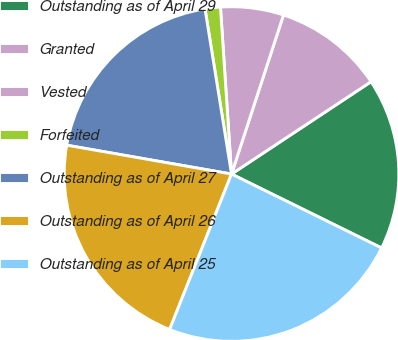Convert chart to OTSL. <chart><loc_0><loc_0><loc_500><loc_500><pie_chart><fcel>Outstanding as of April 29<fcel>Granted<fcel>Vested<fcel>Forfeited<fcel>Outstanding as of April 27<fcel>Outstanding as of April 26<fcel>Outstanding as of April 25<nl><fcel>16.59%<fcel>10.67%<fcel>6.08%<fcel>1.48%<fcel>19.71%<fcel>21.73%<fcel>23.75%<nl></chart> 